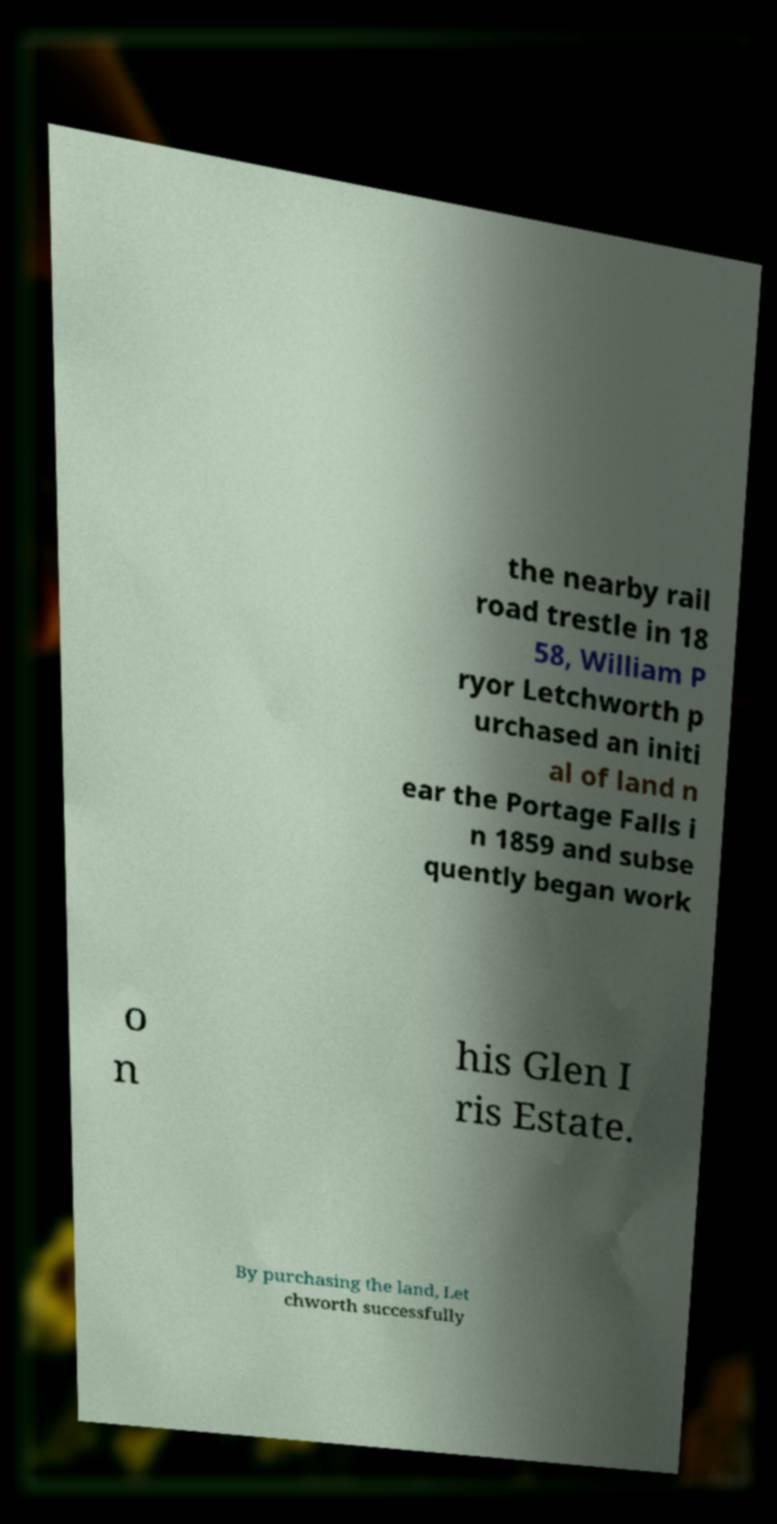Can you accurately transcribe the text from the provided image for me? the nearby rail road trestle in 18 58, William P ryor Letchworth p urchased an initi al of land n ear the Portage Falls i n 1859 and subse quently began work o n his Glen I ris Estate. By purchasing the land, Let chworth successfully 